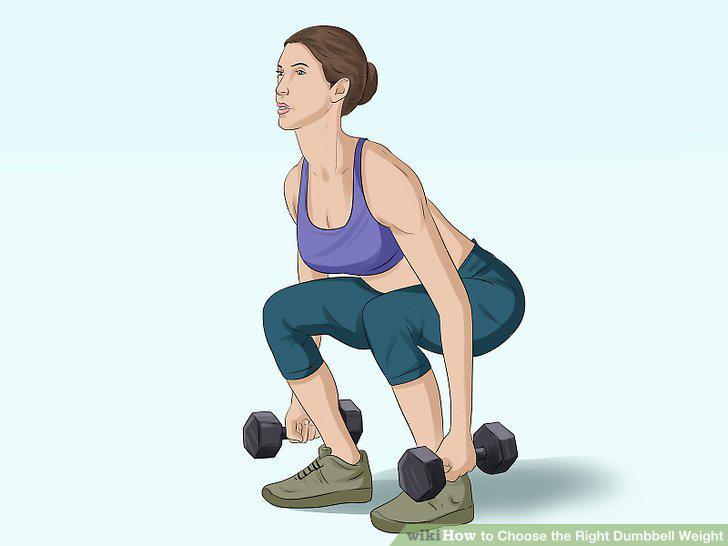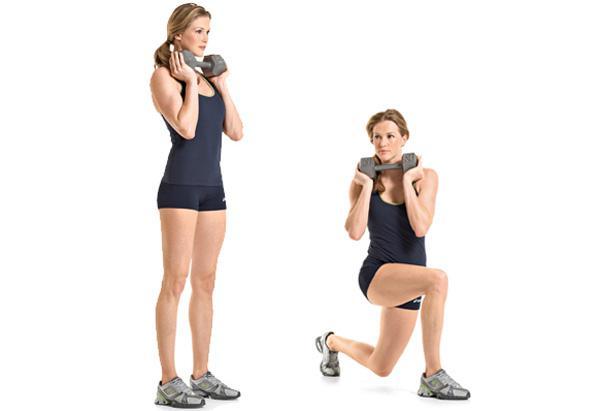The first image is the image on the left, the second image is the image on the right. For the images displayed, is the sentence "There are more people in the image on the right." factually correct? Answer yes or no. Yes. 